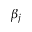<formula> <loc_0><loc_0><loc_500><loc_500>\beta _ { j }</formula> 